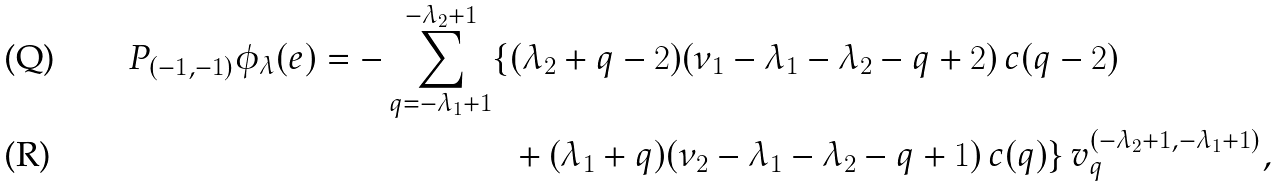Convert formula to latex. <formula><loc_0><loc_0><loc_500><loc_500>P _ { ( - 1 , - 1 ) } \phi _ { \lambda } ( e ) = - \sum _ { q = - \lambda _ { 1 } + 1 } ^ { - \lambda _ { 2 } + 1 } \{ & ( \lambda _ { 2 } + q - 2 ) ( \nu _ { 1 } - \lambda _ { 1 } - \lambda _ { 2 } - q + 2 ) \, c ( q - 2 ) \\ & + ( \lambda _ { 1 } + q ) ( \nu _ { 2 } - \lambda _ { 1 } - \lambda _ { 2 } - q + 1 ) \, c ( q ) \} \, v _ { q } ^ { ( - \lambda _ { 2 } + 1 , - \lambda _ { 1 } + 1 ) } ,</formula> 